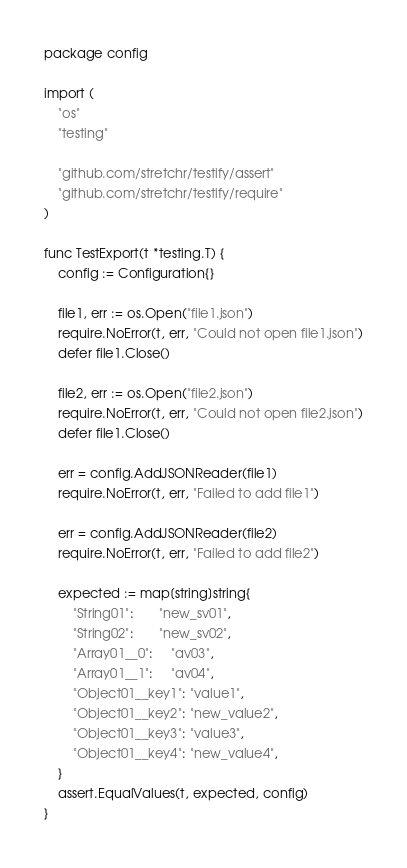Convert code to text. <code><loc_0><loc_0><loc_500><loc_500><_Go_>package config

import (
	"os"
	"testing"

	"github.com/stretchr/testify/assert"
	"github.com/stretchr/testify/require"
)

func TestExport(t *testing.T) {
	config := Configuration{}

	file1, err := os.Open("file1.json")
	require.NoError(t, err, "Could not open file1.json")
	defer file1.Close()

	file2, err := os.Open("file2.json")
	require.NoError(t, err, "Could not open file2.json")
	defer file1.Close()

	err = config.AddJSONReader(file1)
	require.NoError(t, err, "Failed to add file1")

	err = config.AddJSONReader(file2)
	require.NoError(t, err, "Failed to add file2")

	expected := map[string]string{
		"String01":       "new_sv01",
		"String02":       "new_sv02",
		"Array01__0":     "av03",
		"Array01__1":     "av04",
		"Object01__key1": "value1",
		"Object01__key2": "new_value2",
		"Object01__key3": "value3",
		"Object01__key4": "new_value4",
	}
	assert.EqualValues(t, expected, config)
}
</code> 